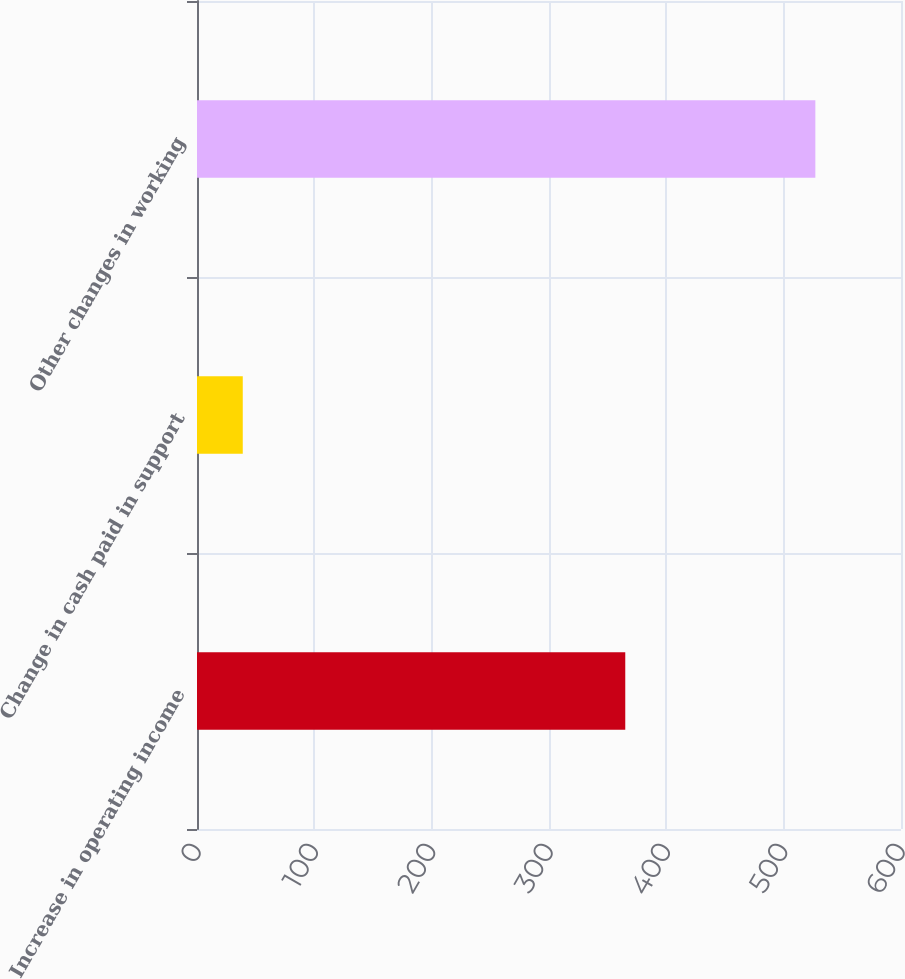<chart> <loc_0><loc_0><loc_500><loc_500><bar_chart><fcel>Increase in operating income<fcel>Change in cash paid in support<fcel>Other changes in working<nl><fcel>365<fcel>39<fcel>527<nl></chart> 